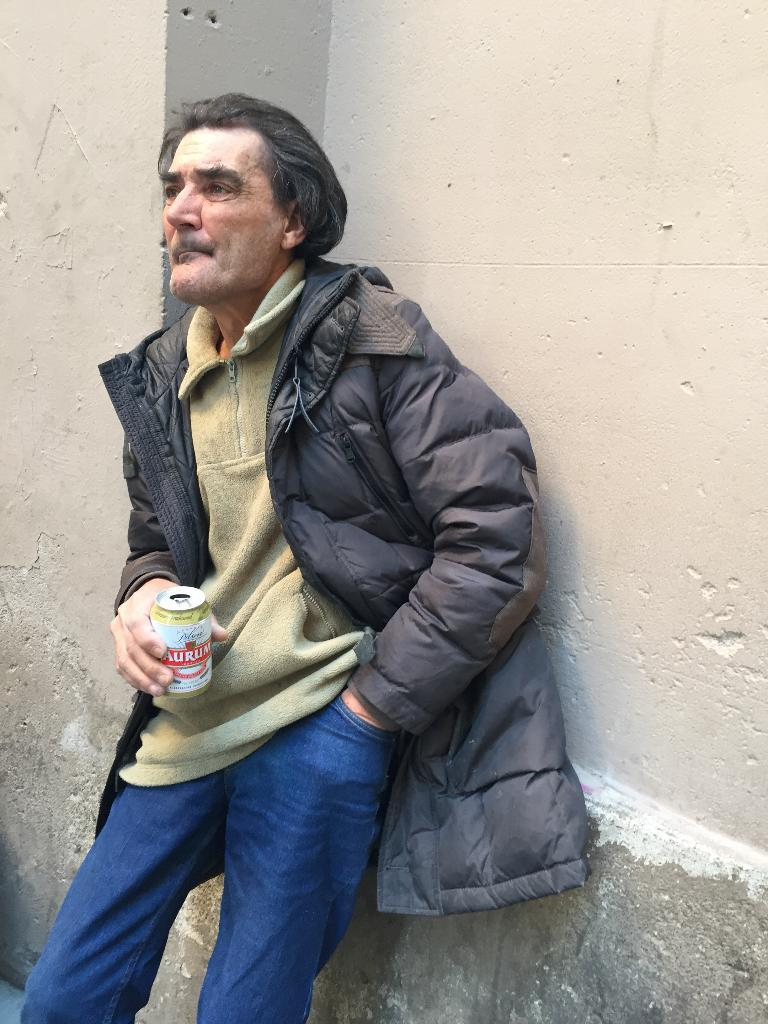What is the main subject of the image? There is a person standing in the image. What is the person holding in his hand? The person is holding a bottle in his hand. What can be seen behind the person? There is a wall behind the person. What type of low-mass son can be seen in the image? There is no son or any reference to mass in the image; it features a person holding a bottle with a wall in the background. 